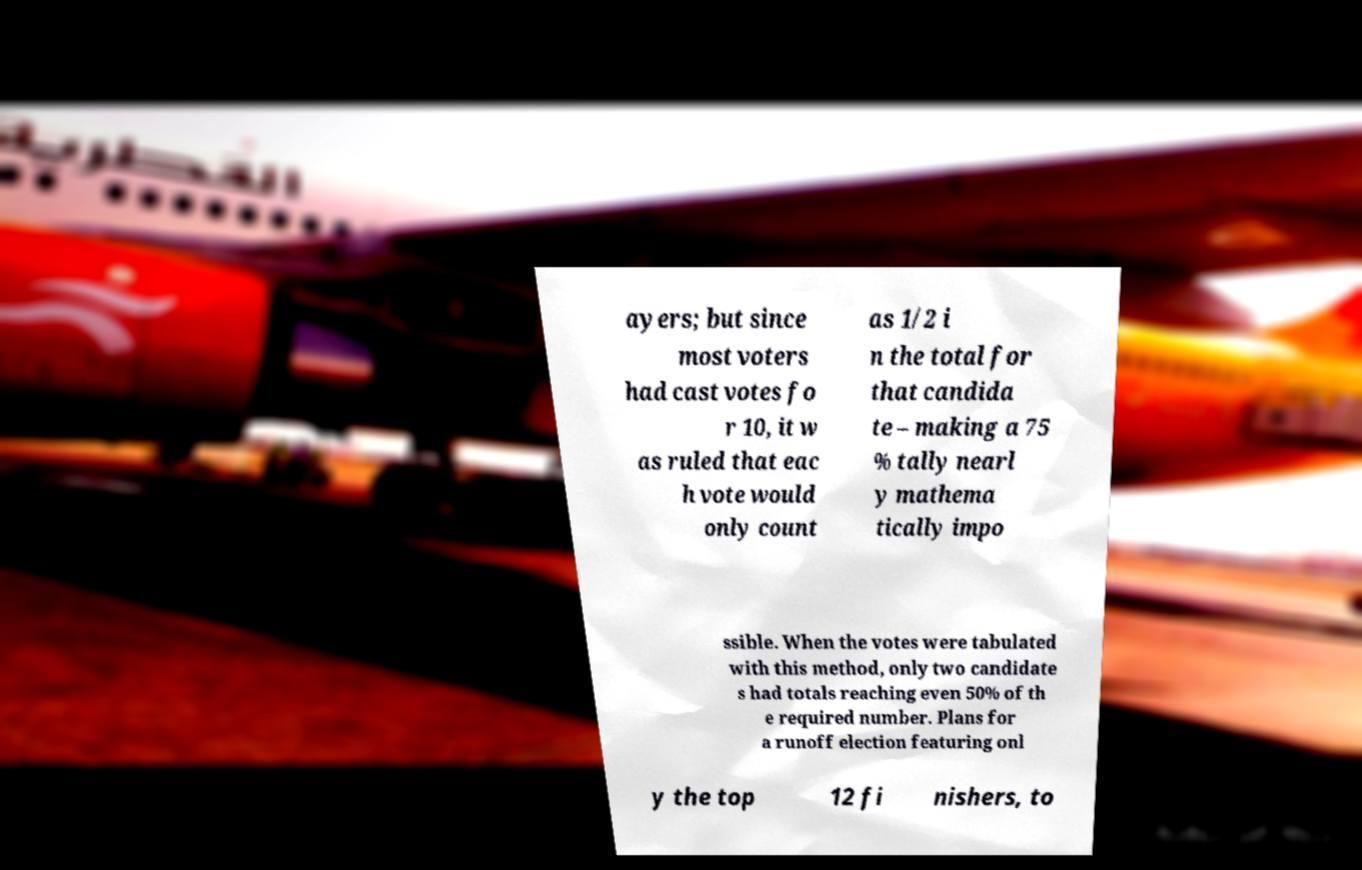Can you read and provide the text displayed in the image?This photo seems to have some interesting text. Can you extract and type it out for me? ayers; but since most voters had cast votes fo r 10, it w as ruled that eac h vote would only count as 1/2 i n the total for that candida te – making a 75 % tally nearl y mathema tically impo ssible. When the votes were tabulated with this method, only two candidate s had totals reaching even 50% of th e required number. Plans for a runoff election featuring onl y the top 12 fi nishers, to 